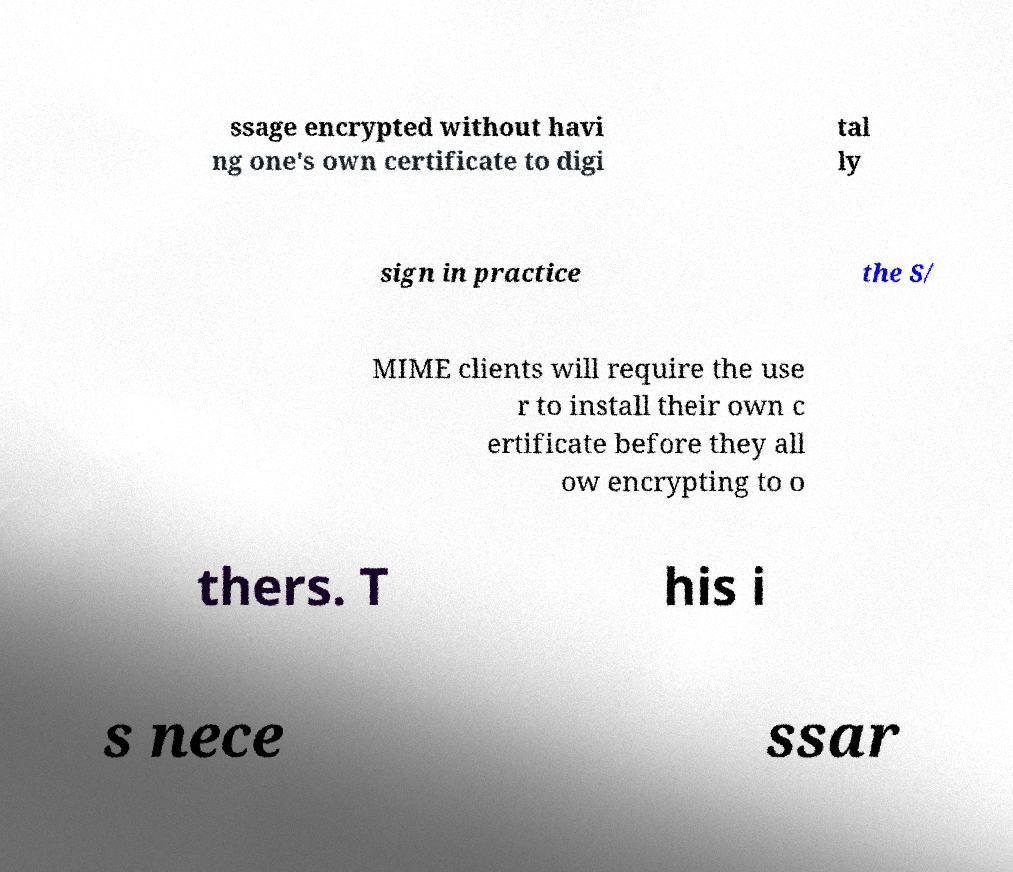Could you extract and type out the text from this image? ssage encrypted without havi ng one's own certificate to digi tal ly sign in practice the S/ MIME clients will require the use r to install their own c ertificate before they all ow encrypting to o thers. T his i s nece ssar 